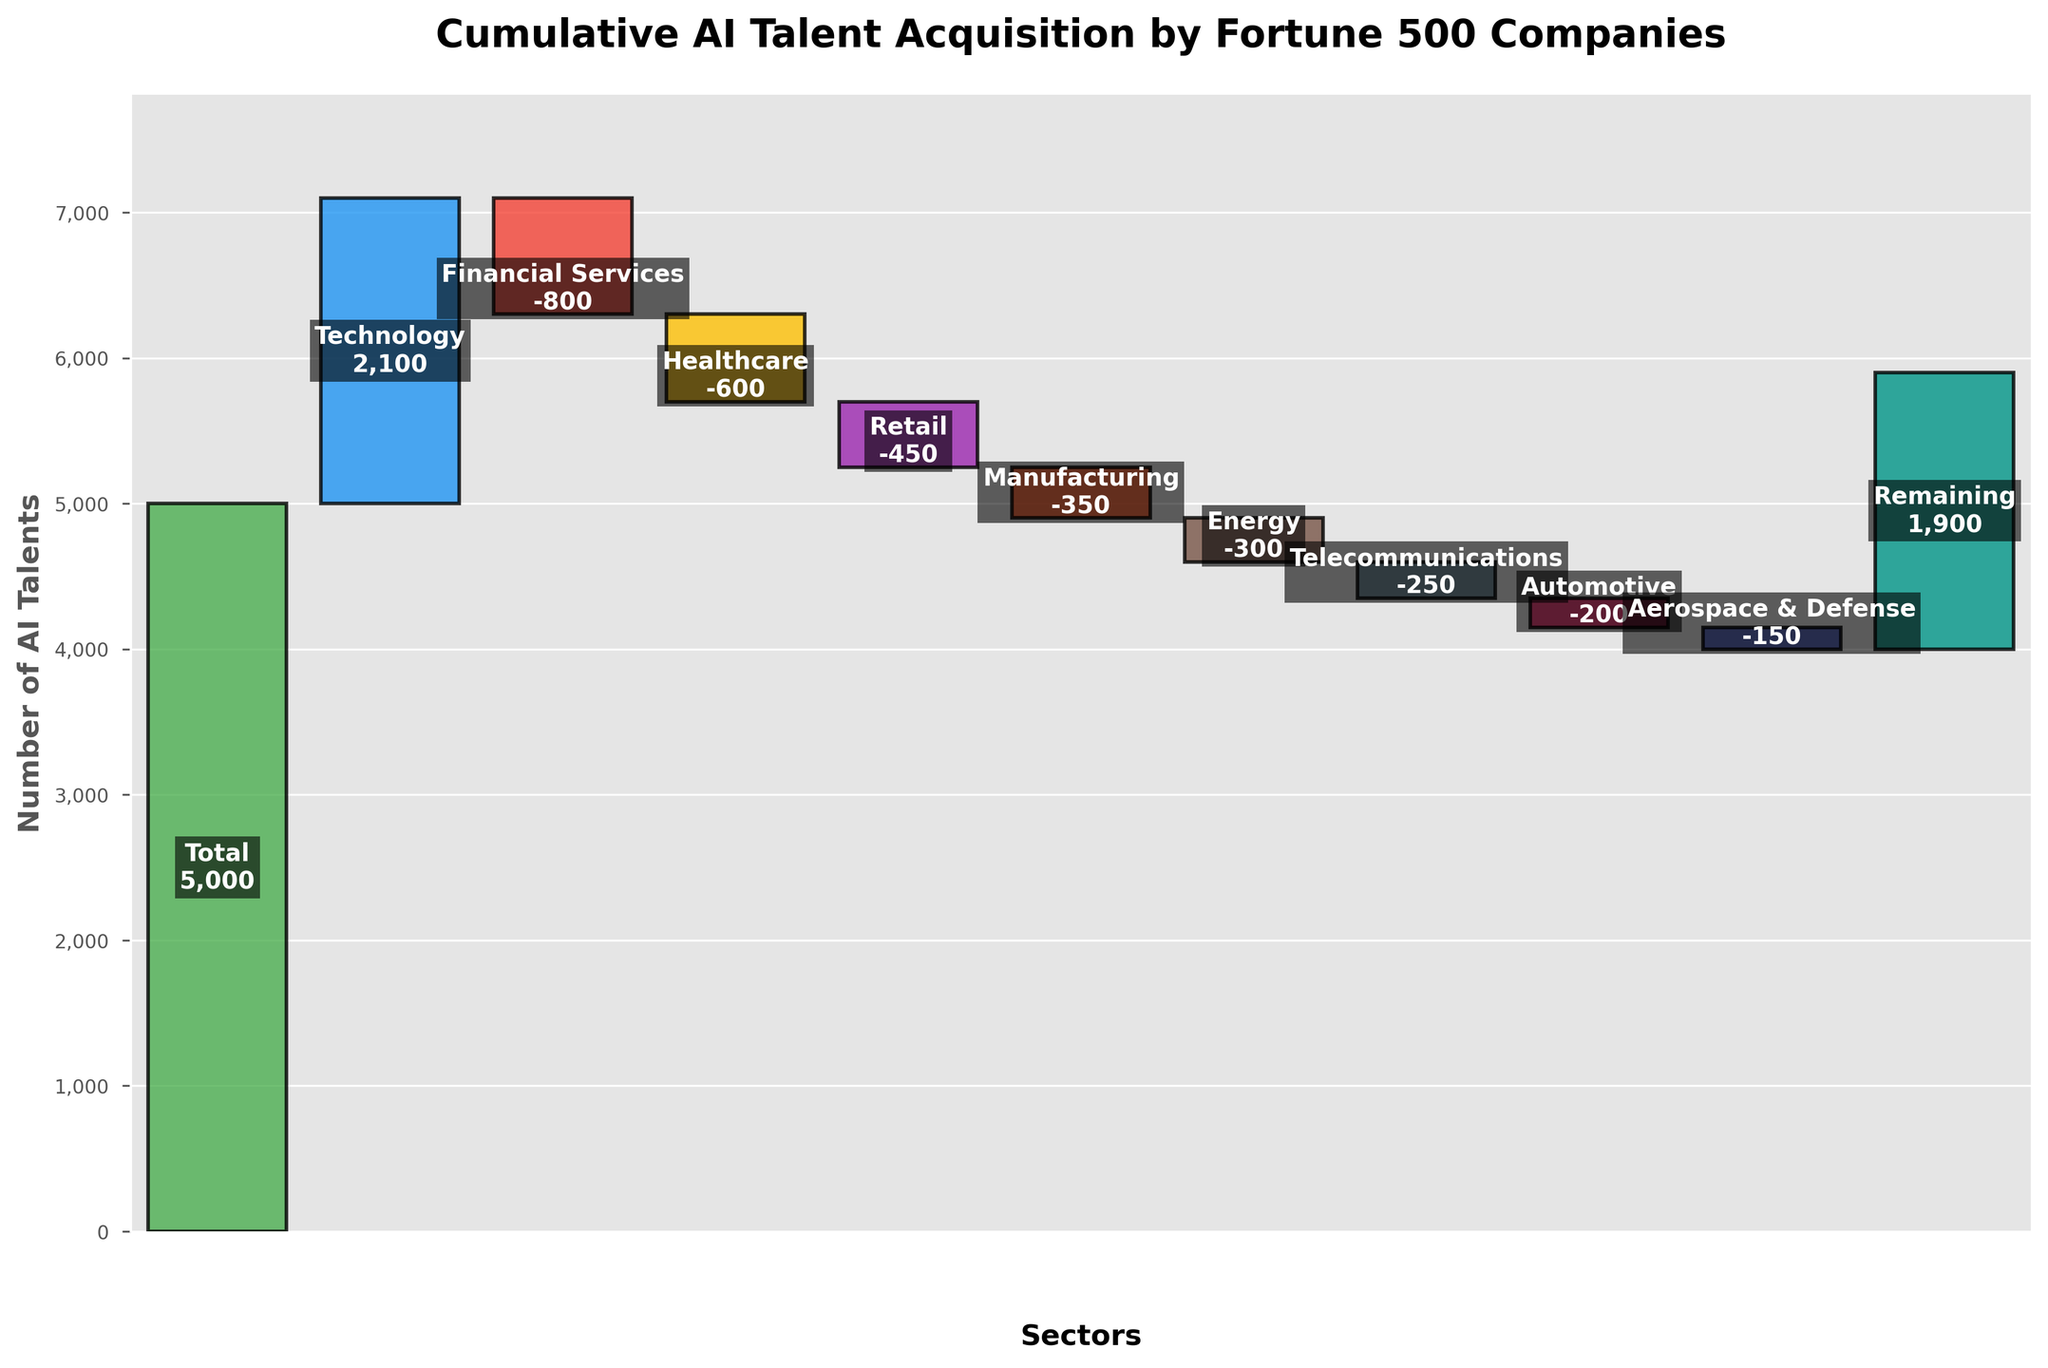What is the title of the chart? The title of the chart is usually found at the top and provides information about what the chart is depicting. In this case, the title is visible at the top above the bars.
Answer: Cumulative AI Talent Acquisition by Fortune 500 Companies How many sectors are displayed on the chart excluding the total and remaining? To answer this, count the distinct bars labeled with sector names excluding 'Total' and 'Remaining'.
Answer: 8 What is the net contribution of the 'Financial Services' and 'Healthcare' sectors together? Both of these sectors have negative values. Summing these values: -800 (Financial Services) + -600 (Healthcare) = -1400.
Answer: -1400 Which sector has the smallest negative contribution to AI talent acquisition? Identify the bar with the smallest negative value (i.e., closest to 0). By comparing, we see the 'Aerospace & Defense' sector has -150, which is less negative than the others.
Answer: Aerospace & Defense How does the 'Technology' sector compare to the 'Retail' sector in terms of AI talent acquisition? Compare the values directly: 'Technology' has 2100, while 'Retail' has -450. 'Technology' contributes positively, whereas 'Retail' has a small negative value.
Answer: Technology sector has a much higher and positive contribution What is the combined remaining AI talent acquisition of the 'Retail', 'Energy', and 'Automotive' sectors? Add the values: -450 (Retail) + -300 (Energy) + -200 (Automotive). This results in: -450 + -300 + -200 = -950.
Answer: -950 What is the significance of the "Remaining" category in the cumulative total? The "Remaining" category likely represents the contribution of other sectors not explicitly named. It's the difference needed to reach the total 5000 after considering listed sectors.
Answer: Represents other sectors' contribution What is the cumulative AI talent acquisition value right before the 'Remaining' category? To find this, add up the values of all sectors before the 'Remaining' category: 2100 (Technology) - 800 (Financial Services) - 600 (Healthcare) - 450 (Retail) - 350 (Manufacturing) - 300 (Energy) - 250 (Telecommunications) - 200 (Automotive) - 150 (Aerospace & Defense). This totals to 3000.
Answer: 3000 How much is the 'Total' AI talent acquisition value more than the sum of negative contributions? First, calculate the sum of negative contributions: -800 (Financial Services) - 600 (Healthcare) - 450 (Retail) - 350 (Manufacturing) - 300 (Energy) - 250 (Telecommunications) - 200 (Automotive) - 150 (Aerospace & Defense) = -3100. Then, compare with the 'Total' which is 5000: 5000 - 3100 = 1900.
Answer: 1900 